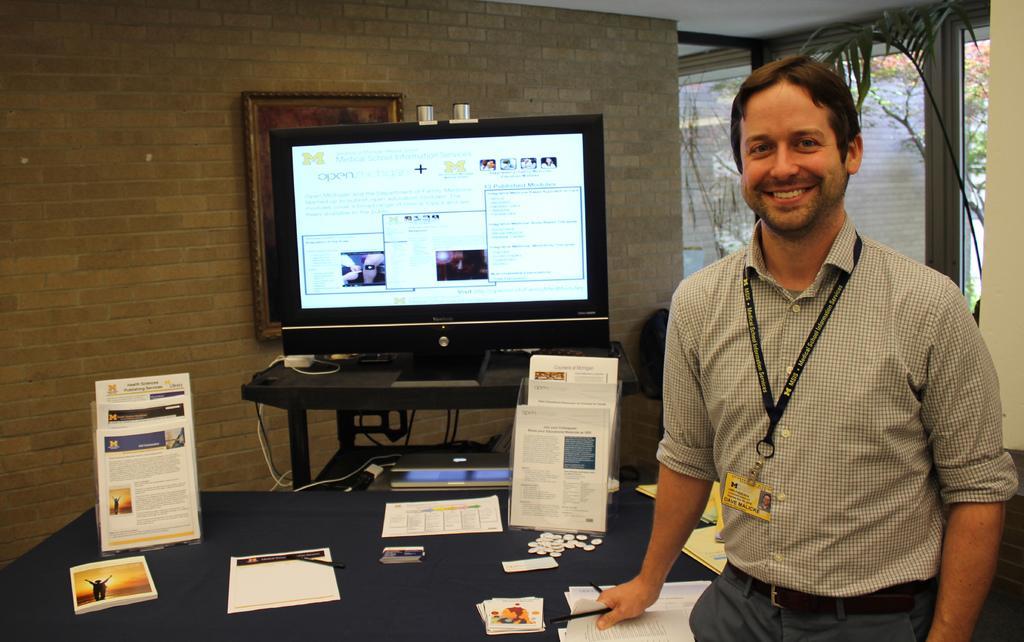Please provide a concise description of this image. Here we can see a man standing and there is a table behind him on the table there are books and papers and in the center there is a monitor screen and the person is laughing 